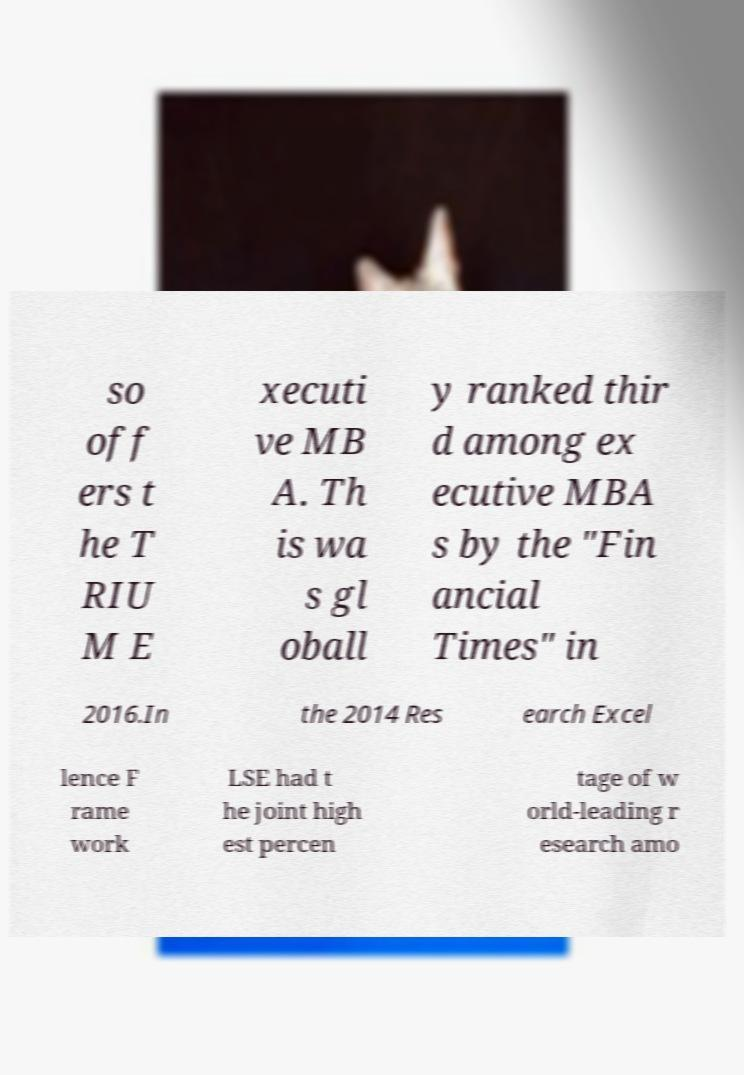I need the written content from this picture converted into text. Can you do that? so off ers t he T RIU M E xecuti ve MB A. Th is wa s gl oball y ranked thir d among ex ecutive MBA s by the "Fin ancial Times" in 2016.In the 2014 Res earch Excel lence F rame work LSE had t he joint high est percen tage of w orld-leading r esearch amo 